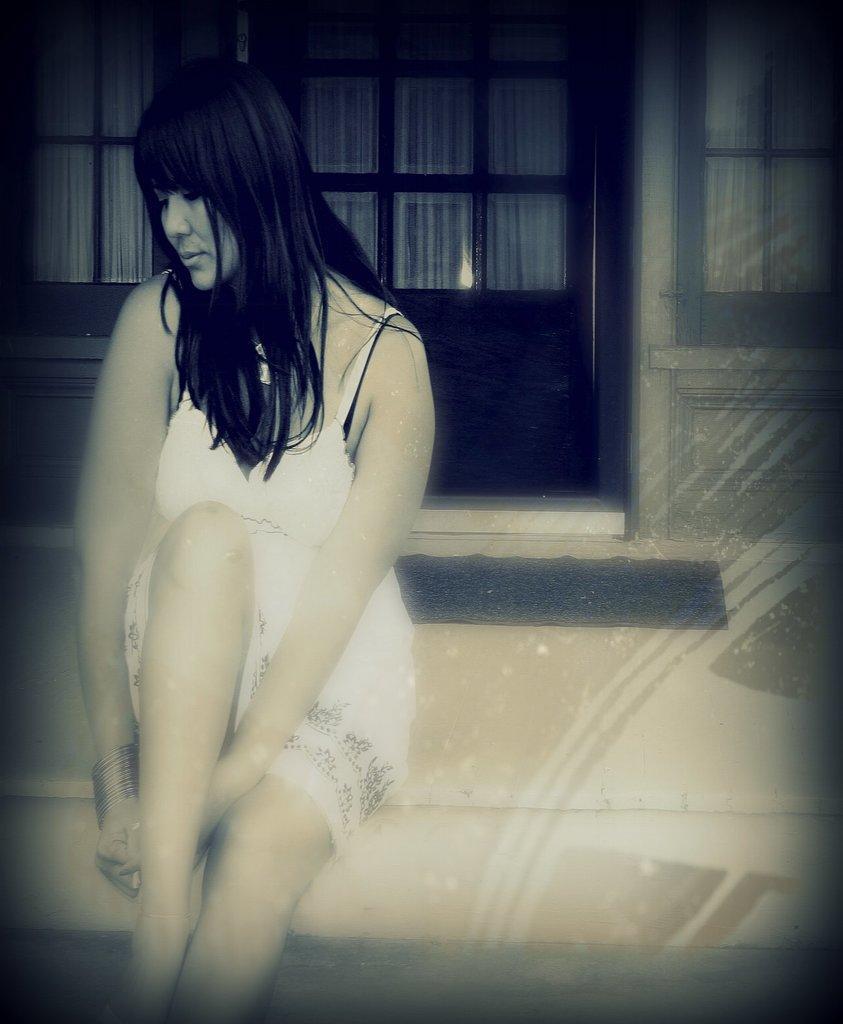Describe this image in one or two sentences. In this image we can see a lady sitting. In the background of the image there is a door. There is a doormat. 